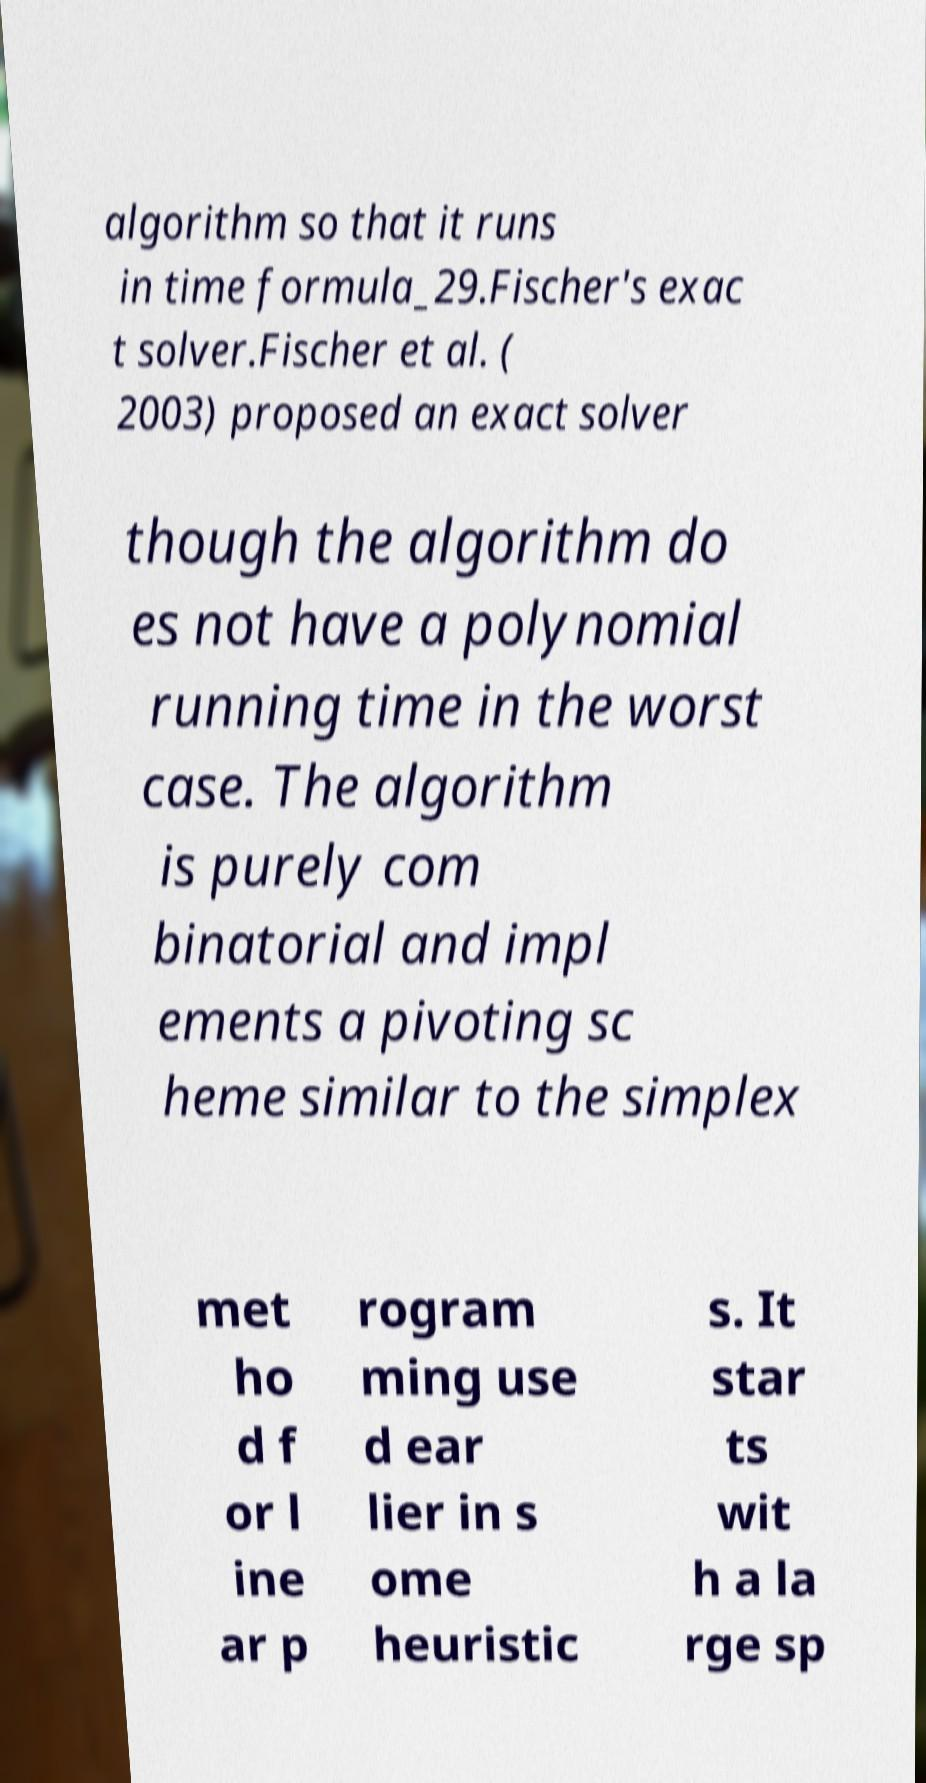Please identify and transcribe the text found in this image. algorithm so that it runs in time formula_29.Fischer's exac t solver.Fischer et al. ( 2003) proposed an exact solver though the algorithm do es not have a polynomial running time in the worst case. The algorithm is purely com binatorial and impl ements a pivoting sc heme similar to the simplex met ho d f or l ine ar p rogram ming use d ear lier in s ome heuristic s. It star ts wit h a la rge sp 